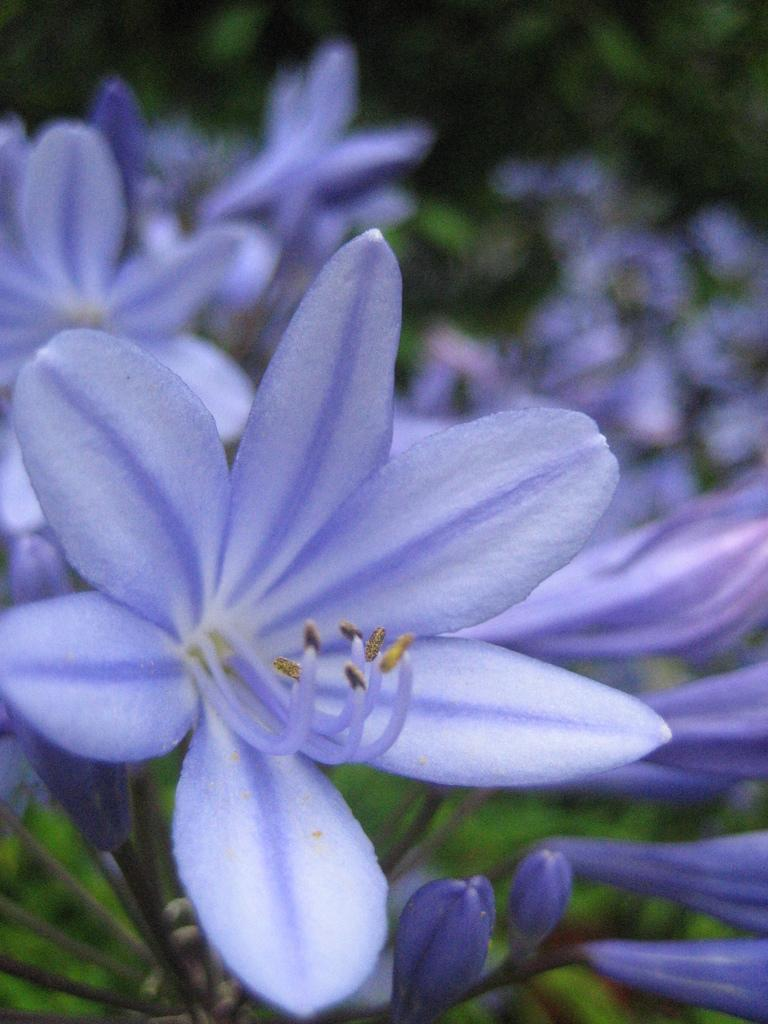What type of plants can be seen in the image? There are flowers and buds in the image. Can you describe the background of the image? The background of the image is blurred, and there is greenery present. What type of humor can be seen in the image? There is no humor present in the image; it features flowers and buds with a blurred background. Can you tell me how many seashores are visible in the image? There are no seashores visible in the image; it features flowers, buds, and a blurred background with greenery. 